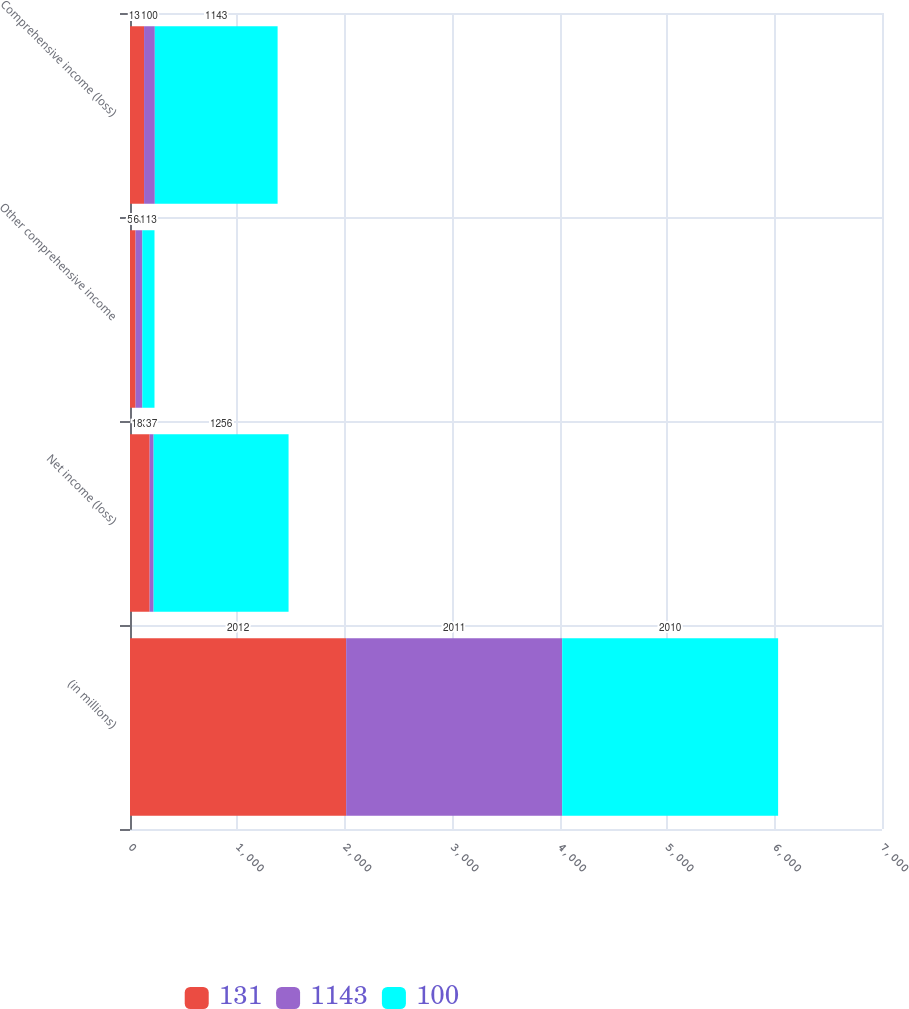Convert chart to OTSL. <chart><loc_0><loc_0><loc_500><loc_500><stacked_bar_chart><ecel><fcel>(in millions)<fcel>Net income (loss)<fcel>Other comprehensive income<fcel>Comprehensive income (loss)<nl><fcel>131<fcel>2012<fcel>183<fcel>52<fcel>131<nl><fcel>1143<fcel>2011<fcel>37<fcel>63<fcel>100<nl><fcel>100<fcel>2010<fcel>1256<fcel>113<fcel>1143<nl></chart> 